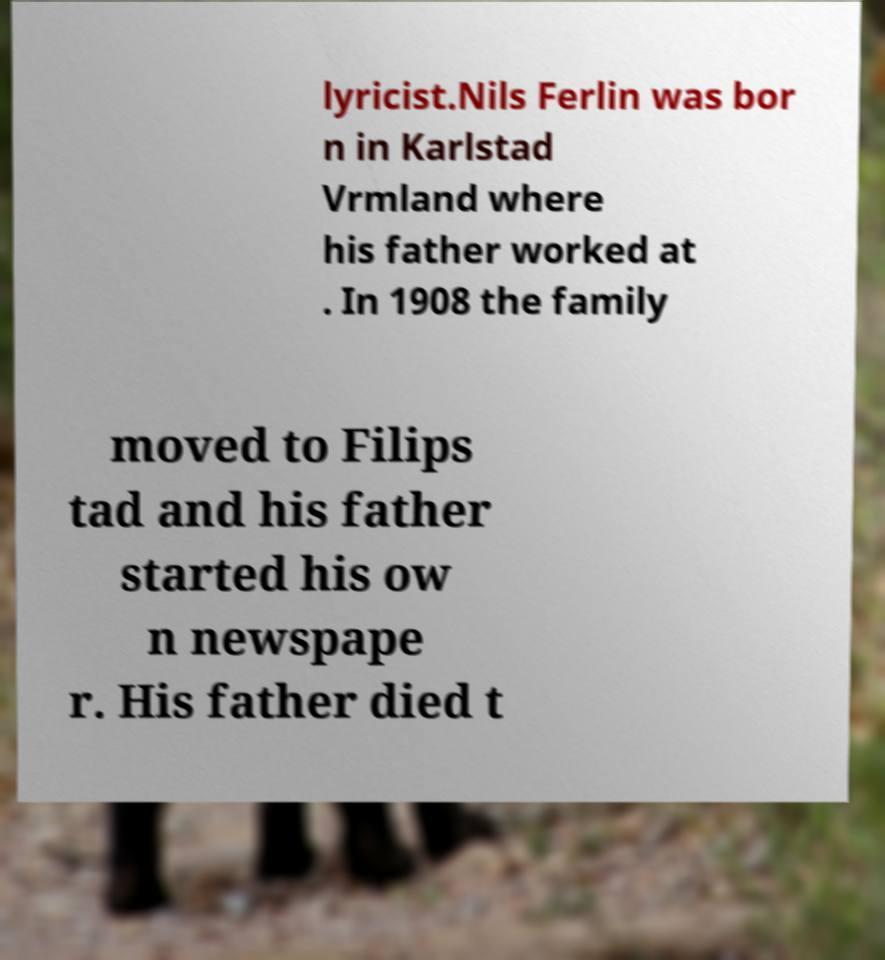I need the written content from this picture converted into text. Can you do that? lyricist.Nils Ferlin was bor n in Karlstad Vrmland where his father worked at . In 1908 the family moved to Filips tad and his father started his ow n newspape r. His father died t 